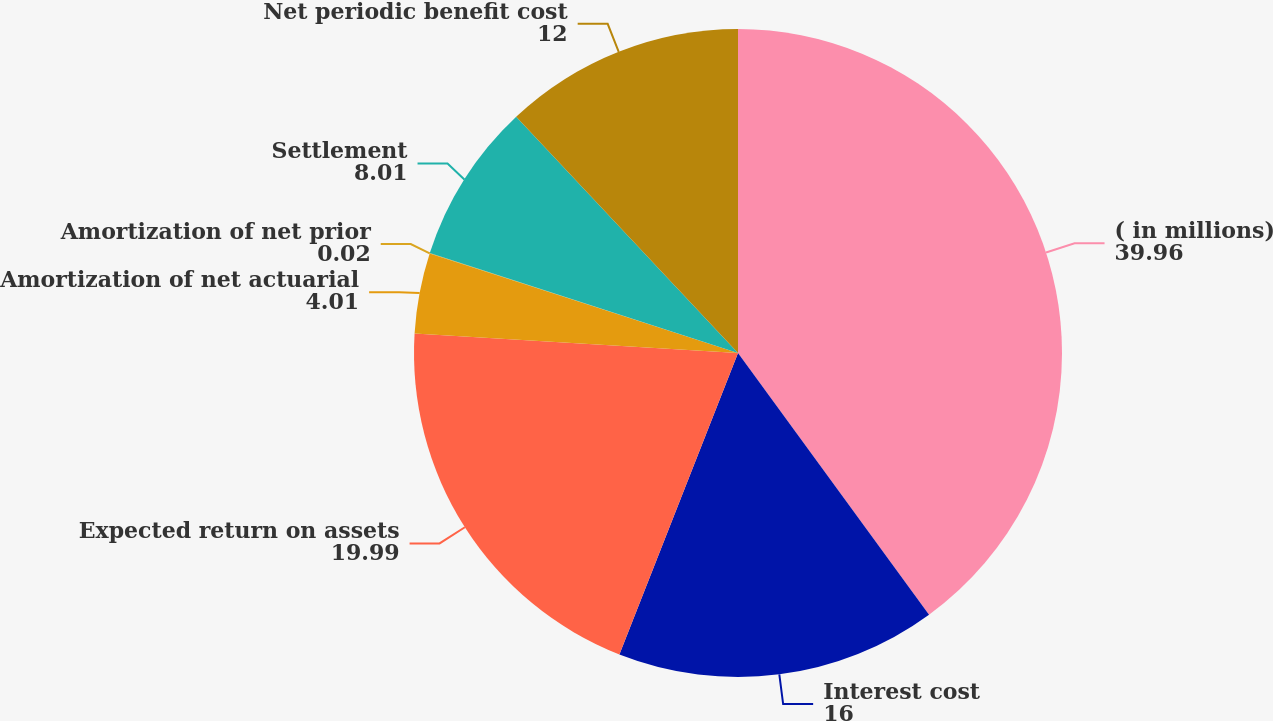<chart> <loc_0><loc_0><loc_500><loc_500><pie_chart><fcel>( in millions)<fcel>Interest cost<fcel>Expected return on assets<fcel>Amortization of net actuarial<fcel>Amortization of net prior<fcel>Settlement<fcel>Net periodic benefit cost<nl><fcel>39.96%<fcel>16.0%<fcel>19.99%<fcel>4.01%<fcel>0.02%<fcel>8.01%<fcel>12.0%<nl></chart> 